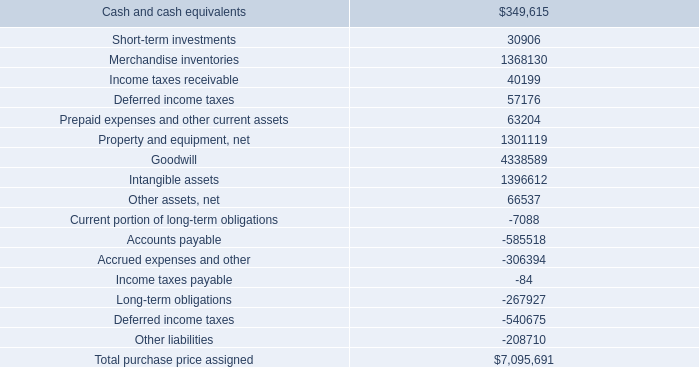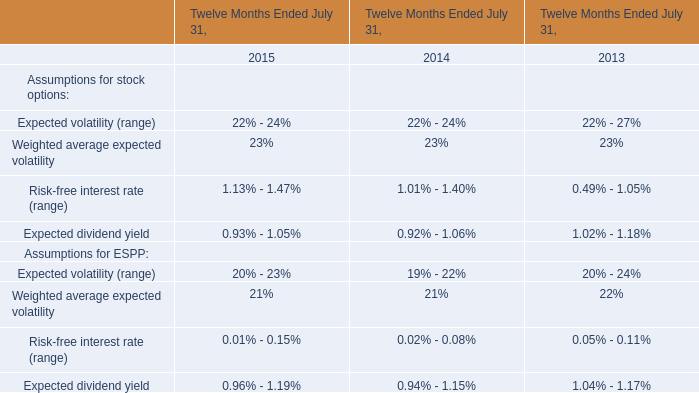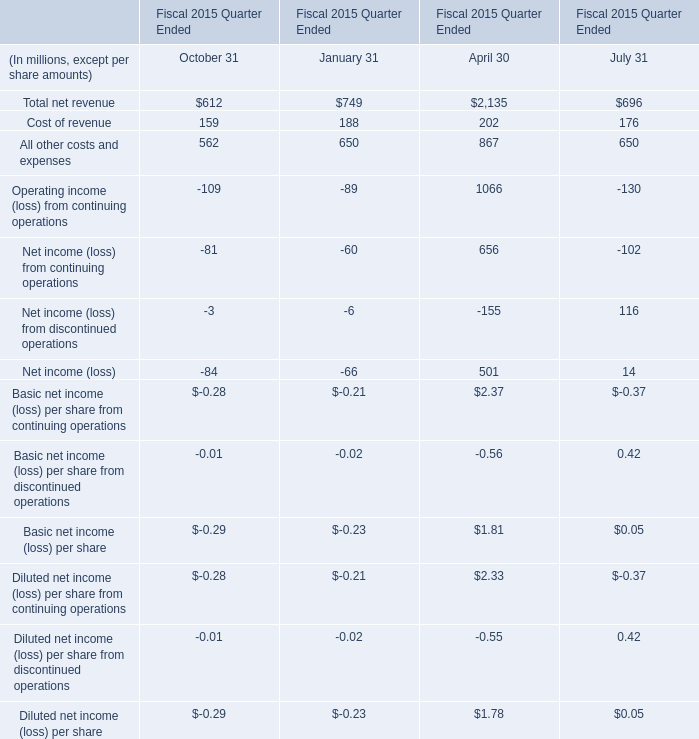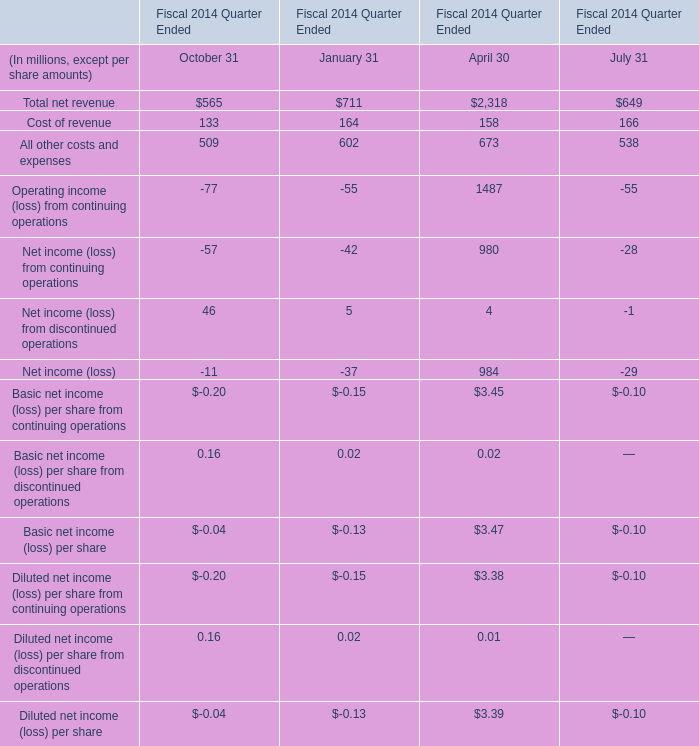What was the average of Net income (loss) for October 31, January 31, and April 30? (in million) 
Computations: (((-11 - 37) + 984) / 3)
Answer: 312.0. 